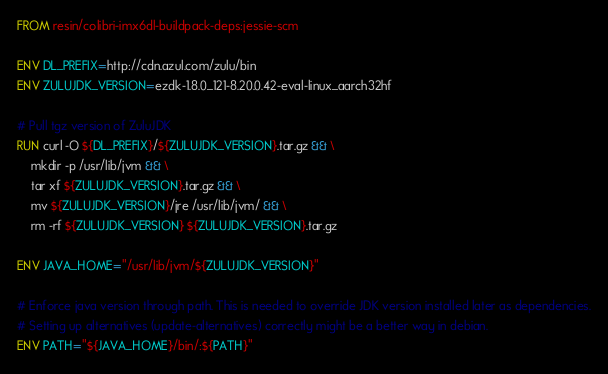<code> <loc_0><loc_0><loc_500><loc_500><_Dockerfile_>FROM resin/colibri-imx6dl-buildpack-deps:jessie-scm

ENV DL_PREFIX=http://cdn.azul.com/zulu/bin
ENV ZULUJDK_VERSION=ezdk-1.8.0_121-8.20.0.42-eval-linux_aarch32hf

# Pull tgz version of ZuluJDK
RUN curl -O ${DL_PREFIX}/${ZULUJDK_VERSION}.tar.gz && \
    mkdir -p /usr/lib/jvm && \
    tar xf ${ZULUJDK_VERSION}.tar.gz && \
    mv ${ZULUJDK_VERSION}/jre /usr/lib/jvm/ && \
    rm -rf ${ZULUJDK_VERSION} ${ZULUJDK_VERSION}.tar.gz

ENV JAVA_HOME="/usr/lib/jvm/${ZULUJDK_VERSION}"

# Enforce java version through path. This is needed to override JDK version installed later as dependencies.
# Setting up alternatives (update-alternatives) correctly might be a better way in debian.
ENV PATH="${JAVA_HOME}/bin/:${PATH}"</code> 